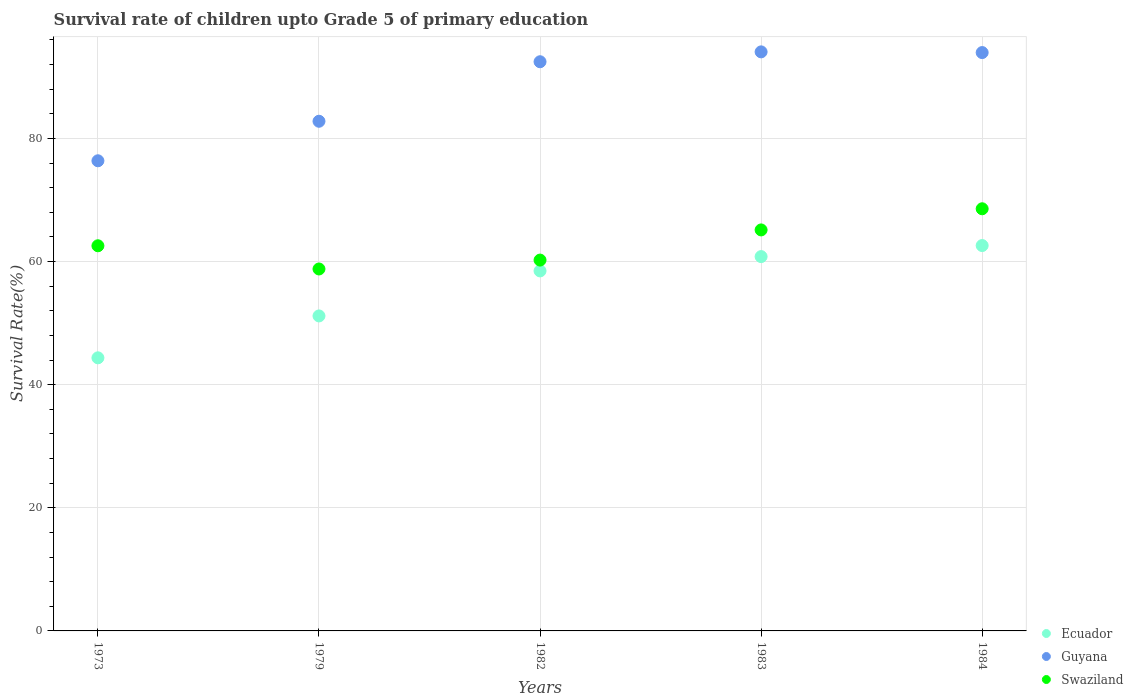How many different coloured dotlines are there?
Your response must be concise. 3. What is the survival rate of children in Guyana in 1979?
Your answer should be very brief. 82.8. Across all years, what is the maximum survival rate of children in Guyana?
Your answer should be very brief. 94.07. Across all years, what is the minimum survival rate of children in Ecuador?
Make the answer very short. 44.37. What is the total survival rate of children in Swaziland in the graph?
Offer a terse response. 315.34. What is the difference between the survival rate of children in Guyana in 1982 and that in 1984?
Offer a terse response. -1.49. What is the difference between the survival rate of children in Ecuador in 1973 and the survival rate of children in Swaziland in 1982?
Ensure brevity in your answer.  -15.88. What is the average survival rate of children in Swaziland per year?
Offer a very short reply. 63.07. In the year 1973, what is the difference between the survival rate of children in Swaziland and survival rate of children in Guyana?
Offer a terse response. -13.81. In how many years, is the survival rate of children in Swaziland greater than 12 %?
Ensure brevity in your answer.  5. What is the ratio of the survival rate of children in Guyana in 1973 to that in 1983?
Your response must be concise. 0.81. Is the survival rate of children in Swaziland in 1983 less than that in 1984?
Offer a very short reply. Yes. What is the difference between the highest and the second highest survival rate of children in Ecuador?
Keep it short and to the point. 1.79. What is the difference between the highest and the lowest survival rate of children in Ecuador?
Keep it short and to the point. 18.24. In how many years, is the survival rate of children in Guyana greater than the average survival rate of children in Guyana taken over all years?
Your answer should be compact. 3. Does the survival rate of children in Ecuador monotonically increase over the years?
Provide a short and direct response. Yes. How many dotlines are there?
Provide a succinct answer. 3. What is the difference between two consecutive major ticks on the Y-axis?
Offer a terse response. 20. Are the values on the major ticks of Y-axis written in scientific E-notation?
Your answer should be compact. No. Does the graph contain any zero values?
Ensure brevity in your answer.  No. Where does the legend appear in the graph?
Ensure brevity in your answer.  Bottom right. What is the title of the graph?
Keep it short and to the point. Survival rate of children upto Grade 5 of primary education. Does "Bangladesh" appear as one of the legend labels in the graph?
Your answer should be very brief. No. What is the label or title of the X-axis?
Offer a terse response. Years. What is the label or title of the Y-axis?
Provide a succinct answer. Survival Rate(%). What is the Survival Rate(%) of Ecuador in 1973?
Your answer should be very brief. 44.37. What is the Survival Rate(%) in Guyana in 1973?
Keep it short and to the point. 76.38. What is the Survival Rate(%) in Swaziland in 1973?
Give a very brief answer. 62.57. What is the Survival Rate(%) of Ecuador in 1979?
Your answer should be compact. 51.17. What is the Survival Rate(%) of Guyana in 1979?
Your answer should be compact. 82.8. What is the Survival Rate(%) in Swaziland in 1979?
Offer a terse response. 58.8. What is the Survival Rate(%) in Ecuador in 1982?
Offer a terse response. 58.49. What is the Survival Rate(%) in Guyana in 1982?
Your answer should be very brief. 92.47. What is the Survival Rate(%) of Swaziland in 1982?
Your answer should be very brief. 60.24. What is the Survival Rate(%) of Ecuador in 1983?
Offer a very short reply. 60.81. What is the Survival Rate(%) of Guyana in 1983?
Offer a terse response. 94.07. What is the Survival Rate(%) of Swaziland in 1983?
Give a very brief answer. 65.14. What is the Survival Rate(%) of Ecuador in 1984?
Offer a terse response. 62.61. What is the Survival Rate(%) of Guyana in 1984?
Offer a very short reply. 93.96. What is the Survival Rate(%) in Swaziland in 1984?
Give a very brief answer. 68.58. Across all years, what is the maximum Survival Rate(%) of Ecuador?
Give a very brief answer. 62.61. Across all years, what is the maximum Survival Rate(%) of Guyana?
Ensure brevity in your answer.  94.07. Across all years, what is the maximum Survival Rate(%) of Swaziland?
Offer a terse response. 68.58. Across all years, what is the minimum Survival Rate(%) of Ecuador?
Make the answer very short. 44.37. Across all years, what is the minimum Survival Rate(%) in Guyana?
Your answer should be compact. 76.38. Across all years, what is the minimum Survival Rate(%) in Swaziland?
Provide a short and direct response. 58.8. What is the total Survival Rate(%) of Ecuador in the graph?
Provide a succinct answer. 277.44. What is the total Survival Rate(%) in Guyana in the graph?
Your response must be concise. 439.67. What is the total Survival Rate(%) in Swaziland in the graph?
Your answer should be compact. 315.34. What is the difference between the Survival Rate(%) of Ecuador in 1973 and that in 1979?
Keep it short and to the point. -6.81. What is the difference between the Survival Rate(%) in Guyana in 1973 and that in 1979?
Your answer should be compact. -6.42. What is the difference between the Survival Rate(%) in Swaziland in 1973 and that in 1979?
Give a very brief answer. 3.77. What is the difference between the Survival Rate(%) of Ecuador in 1973 and that in 1982?
Provide a short and direct response. -14.12. What is the difference between the Survival Rate(%) in Guyana in 1973 and that in 1982?
Keep it short and to the point. -16.09. What is the difference between the Survival Rate(%) of Swaziland in 1973 and that in 1982?
Provide a succinct answer. 2.33. What is the difference between the Survival Rate(%) in Ecuador in 1973 and that in 1983?
Your answer should be very brief. -16.45. What is the difference between the Survival Rate(%) of Guyana in 1973 and that in 1983?
Provide a short and direct response. -17.69. What is the difference between the Survival Rate(%) in Swaziland in 1973 and that in 1983?
Provide a succinct answer. -2.58. What is the difference between the Survival Rate(%) of Ecuador in 1973 and that in 1984?
Provide a succinct answer. -18.24. What is the difference between the Survival Rate(%) in Guyana in 1973 and that in 1984?
Offer a very short reply. -17.58. What is the difference between the Survival Rate(%) of Swaziland in 1973 and that in 1984?
Ensure brevity in your answer.  -6.01. What is the difference between the Survival Rate(%) in Ecuador in 1979 and that in 1982?
Offer a very short reply. -7.31. What is the difference between the Survival Rate(%) in Guyana in 1979 and that in 1982?
Offer a terse response. -9.67. What is the difference between the Survival Rate(%) in Swaziland in 1979 and that in 1982?
Make the answer very short. -1.44. What is the difference between the Survival Rate(%) of Ecuador in 1979 and that in 1983?
Offer a terse response. -9.64. What is the difference between the Survival Rate(%) of Guyana in 1979 and that in 1983?
Your answer should be compact. -11.27. What is the difference between the Survival Rate(%) of Swaziland in 1979 and that in 1983?
Ensure brevity in your answer.  -6.34. What is the difference between the Survival Rate(%) of Ecuador in 1979 and that in 1984?
Keep it short and to the point. -11.43. What is the difference between the Survival Rate(%) of Guyana in 1979 and that in 1984?
Offer a very short reply. -11.16. What is the difference between the Survival Rate(%) of Swaziland in 1979 and that in 1984?
Give a very brief answer. -9.78. What is the difference between the Survival Rate(%) in Ecuador in 1982 and that in 1983?
Make the answer very short. -2.33. What is the difference between the Survival Rate(%) in Guyana in 1982 and that in 1983?
Offer a terse response. -1.6. What is the difference between the Survival Rate(%) in Swaziland in 1982 and that in 1983?
Offer a very short reply. -4.9. What is the difference between the Survival Rate(%) in Ecuador in 1982 and that in 1984?
Provide a short and direct response. -4.12. What is the difference between the Survival Rate(%) of Guyana in 1982 and that in 1984?
Make the answer very short. -1.49. What is the difference between the Survival Rate(%) in Swaziland in 1982 and that in 1984?
Make the answer very short. -8.34. What is the difference between the Survival Rate(%) of Ecuador in 1983 and that in 1984?
Give a very brief answer. -1.79. What is the difference between the Survival Rate(%) of Guyana in 1983 and that in 1984?
Provide a succinct answer. 0.11. What is the difference between the Survival Rate(%) in Swaziland in 1983 and that in 1984?
Provide a succinct answer. -3.44. What is the difference between the Survival Rate(%) of Ecuador in 1973 and the Survival Rate(%) of Guyana in 1979?
Provide a succinct answer. -38.43. What is the difference between the Survival Rate(%) in Ecuador in 1973 and the Survival Rate(%) in Swaziland in 1979?
Offer a very short reply. -14.44. What is the difference between the Survival Rate(%) in Guyana in 1973 and the Survival Rate(%) in Swaziland in 1979?
Your answer should be very brief. 17.58. What is the difference between the Survival Rate(%) of Ecuador in 1973 and the Survival Rate(%) of Guyana in 1982?
Offer a very short reply. -48.1. What is the difference between the Survival Rate(%) of Ecuador in 1973 and the Survival Rate(%) of Swaziland in 1982?
Ensure brevity in your answer.  -15.88. What is the difference between the Survival Rate(%) in Guyana in 1973 and the Survival Rate(%) in Swaziland in 1982?
Make the answer very short. 16.13. What is the difference between the Survival Rate(%) of Ecuador in 1973 and the Survival Rate(%) of Guyana in 1983?
Keep it short and to the point. -49.7. What is the difference between the Survival Rate(%) of Ecuador in 1973 and the Survival Rate(%) of Swaziland in 1983?
Your answer should be very brief. -20.78. What is the difference between the Survival Rate(%) of Guyana in 1973 and the Survival Rate(%) of Swaziland in 1983?
Provide a succinct answer. 11.23. What is the difference between the Survival Rate(%) of Ecuador in 1973 and the Survival Rate(%) of Guyana in 1984?
Offer a very short reply. -49.59. What is the difference between the Survival Rate(%) in Ecuador in 1973 and the Survival Rate(%) in Swaziland in 1984?
Give a very brief answer. -24.21. What is the difference between the Survival Rate(%) in Guyana in 1973 and the Survival Rate(%) in Swaziland in 1984?
Your answer should be compact. 7.8. What is the difference between the Survival Rate(%) of Ecuador in 1979 and the Survival Rate(%) of Guyana in 1982?
Offer a very short reply. -41.29. What is the difference between the Survival Rate(%) in Ecuador in 1979 and the Survival Rate(%) in Swaziland in 1982?
Your answer should be very brief. -9.07. What is the difference between the Survival Rate(%) of Guyana in 1979 and the Survival Rate(%) of Swaziland in 1982?
Make the answer very short. 22.55. What is the difference between the Survival Rate(%) of Ecuador in 1979 and the Survival Rate(%) of Guyana in 1983?
Your response must be concise. -42.9. What is the difference between the Survival Rate(%) of Ecuador in 1979 and the Survival Rate(%) of Swaziland in 1983?
Offer a terse response. -13.97. What is the difference between the Survival Rate(%) of Guyana in 1979 and the Survival Rate(%) of Swaziland in 1983?
Keep it short and to the point. 17.65. What is the difference between the Survival Rate(%) of Ecuador in 1979 and the Survival Rate(%) of Guyana in 1984?
Make the answer very short. -42.78. What is the difference between the Survival Rate(%) in Ecuador in 1979 and the Survival Rate(%) in Swaziland in 1984?
Your answer should be compact. -17.41. What is the difference between the Survival Rate(%) of Guyana in 1979 and the Survival Rate(%) of Swaziland in 1984?
Provide a succinct answer. 14.22. What is the difference between the Survival Rate(%) in Ecuador in 1982 and the Survival Rate(%) in Guyana in 1983?
Your response must be concise. -35.58. What is the difference between the Survival Rate(%) in Ecuador in 1982 and the Survival Rate(%) in Swaziland in 1983?
Keep it short and to the point. -6.66. What is the difference between the Survival Rate(%) in Guyana in 1982 and the Survival Rate(%) in Swaziland in 1983?
Offer a terse response. 27.32. What is the difference between the Survival Rate(%) in Ecuador in 1982 and the Survival Rate(%) in Guyana in 1984?
Your answer should be compact. -35.47. What is the difference between the Survival Rate(%) in Ecuador in 1982 and the Survival Rate(%) in Swaziland in 1984?
Offer a very short reply. -10.09. What is the difference between the Survival Rate(%) of Guyana in 1982 and the Survival Rate(%) of Swaziland in 1984?
Offer a very short reply. 23.89. What is the difference between the Survival Rate(%) in Ecuador in 1983 and the Survival Rate(%) in Guyana in 1984?
Ensure brevity in your answer.  -33.14. What is the difference between the Survival Rate(%) in Ecuador in 1983 and the Survival Rate(%) in Swaziland in 1984?
Provide a succinct answer. -7.77. What is the difference between the Survival Rate(%) of Guyana in 1983 and the Survival Rate(%) of Swaziland in 1984?
Your response must be concise. 25.49. What is the average Survival Rate(%) in Ecuador per year?
Offer a terse response. 55.49. What is the average Survival Rate(%) in Guyana per year?
Keep it short and to the point. 87.93. What is the average Survival Rate(%) in Swaziland per year?
Your answer should be very brief. 63.07. In the year 1973, what is the difference between the Survival Rate(%) of Ecuador and Survival Rate(%) of Guyana?
Offer a terse response. -32.01. In the year 1973, what is the difference between the Survival Rate(%) in Ecuador and Survival Rate(%) in Swaziland?
Make the answer very short. -18.2. In the year 1973, what is the difference between the Survival Rate(%) in Guyana and Survival Rate(%) in Swaziland?
Your response must be concise. 13.81. In the year 1979, what is the difference between the Survival Rate(%) of Ecuador and Survival Rate(%) of Guyana?
Provide a succinct answer. -31.63. In the year 1979, what is the difference between the Survival Rate(%) of Ecuador and Survival Rate(%) of Swaziland?
Offer a very short reply. -7.63. In the year 1979, what is the difference between the Survival Rate(%) in Guyana and Survival Rate(%) in Swaziland?
Offer a very short reply. 24. In the year 1982, what is the difference between the Survival Rate(%) of Ecuador and Survival Rate(%) of Guyana?
Ensure brevity in your answer.  -33.98. In the year 1982, what is the difference between the Survival Rate(%) of Ecuador and Survival Rate(%) of Swaziland?
Offer a terse response. -1.76. In the year 1982, what is the difference between the Survival Rate(%) in Guyana and Survival Rate(%) in Swaziland?
Ensure brevity in your answer.  32.22. In the year 1983, what is the difference between the Survival Rate(%) of Ecuador and Survival Rate(%) of Guyana?
Offer a very short reply. -33.26. In the year 1983, what is the difference between the Survival Rate(%) in Ecuador and Survival Rate(%) in Swaziland?
Keep it short and to the point. -4.33. In the year 1983, what is the difference between the Survival Rate(%) of Guyana and Survival Rate(%) of Swaziland?
Keep it short and to the point. 28.92. In the year 1984, what is the difference between the Survival Rate(%) of Ecuador and Survival Rate(%) of Guyana?
Provide a short and direct response. -31.35. In the year 1984, what is the difference between the Survival Rate(%) in Ecuador and Survival Rate(%) in Swaziland?
Your response must be concise. -5.97. In the year 1984, what is the difference between the Survival Rate(%) in Guyana and Survival Rate(%) in Swaziland?
Offer a very short reply. 25.38. What is the ratio of the Survival Rate(%) of Ecuador in 1973 to that in 1979?
Offer a terse response. 0.87. What is the ratio of the Survival Rate(%) of Guyana in 1973 to that in 1979?
Your answer should be very brief. 0.92. What is the ratio of the Survival Rate(%) of Swaziland in 1973 to that in 1979?
Your response must be concise. 1.06. What is the ratio of the Survival Rate(%) of Ecuador in 1973 to that in 1982?
Offer a very short reply. 0.76. What is the ratio of the Survival Rate(%) in Guyana in 1973 to that in 1982?
Provide a short and direct response. 0.83. What is the ratio of the Survival Rate(%) of Swaziland in 1973 to that in 1982?
Your answer should be very brief. 1.04. What is the ratio of the Survival Rate(%) in Ecuador in 1973 to that in 1983?
Keep it short and to the point. 0.73. What is the ratio of the Survival Rate(%) of Guyana in 1973 to that in 1983?
Offer a very short reply. 0.81. What is the ratio of the Survival Rate(%) in Swaziland in 1973 to that in 1983?
Your answer should be compact. 0.96. What is the ratio of the Survival Rate(%) of Ecuador in 1973 to that in 1984?
Make the answer very short. 0.71. What is the ratio of the Survival Rate(%) of Guyana in 1973 to that in 1984?
Give a very brief answer. 0.81. What is the ratio of the Survival Rate(%) in Swaziland in 1973 to that in 1984?
Your answer should be very brief. 0.91. What is the ratio of the Survival Rate(%) of Guyana in 1979 to that in 1982?
Provide a succinct answer. 0.9. What is the ratio of the Survival Rate(%) of Swaziland in 1979 to that in 1982?
Your response must be concise. 0.98. What is the ratio of the Survival Rate(%) in Ecuador in 1979 to that in 1983?
Your response must be concise. 0.84. What is the ratio of the Survival Rate(%) of Guyana in 1979 to that in 1983?
Provide a succinct answer. 0.88. What is the ratio of the Survival Rate(%) in Swaziland in 1979 to that in 1983?
Provide a short and direct response. 0.9. What is the ratio of the Survival Rate(%) in Ecuador in 1979 to that in 1984?
Your answer should be compact. 0.82. What is the ratio of the Survival Rate(%) of Guyana in 1979 to that in 1984?
Your answer should be very brief. 0.88. What is the ratio of the Survival Rate(%) in Swaziland in 1979 to that in 1984?
Your answer should be very brief. 0.86. What is the ratio of the Survival Rate(%) in Ecuador in 1982 to that in 1983?
Provide a succinct answer. 0.96. What is the ratio of the Survival Rate(%) of Guyana in 1982 to that in 1983?
Your answer should be compact. 0.98. What is the ratio of the Survival Rate(%) in Swaziland in 1982 to that in 1983?
Provide a short and direct response. 0.92. What is the ratio of the Survival Rate(%) in Ecuador in 1982 to that in 1984?
Offer a terse response. 0.93. What is the ratio of the Survival Rate(%) of Guyana in 1982 to that in 1984?
Make the answer very short. 0.98. What is the ratio of the Survival Rate(%) in Swaziland in 1982 to that in 1984?
Give a very brief answer. 0.88. What is the ratio of the Survival Rate(%) of Ecuador in 1983 to that in 1984?
Keep it short and to the point. 0.97. What is the ratio of the Survival Rate(%) in Swaziland in 1983 to that in 1984?
Keep it short and to the point. 0.95. What is the difference between the highest and the second highest Survival Rate(%) of Ecuador?
Make the answer very short. 1.79. What is the difference between the highest and the second highest Survival Rate(%) of Guyana?
Your answer should be very brief. 0.11. What is the difference between the highest and the second highest Survival Rate(%) of Swaziland?
Make the answer very short. 3.44. What is the difference between the highest and the lowest Survival Rate(%) of Ecuador?
Your response must be concise. 18.24. What is the difference between the highest and the lowest Survival Rate(%) of Guyana?
Offer a very short reply. 17.69. What is the difference between the highest and the lowest Survival Rate(%) of Swaziland?
Offer a very short reply. 9.78. 